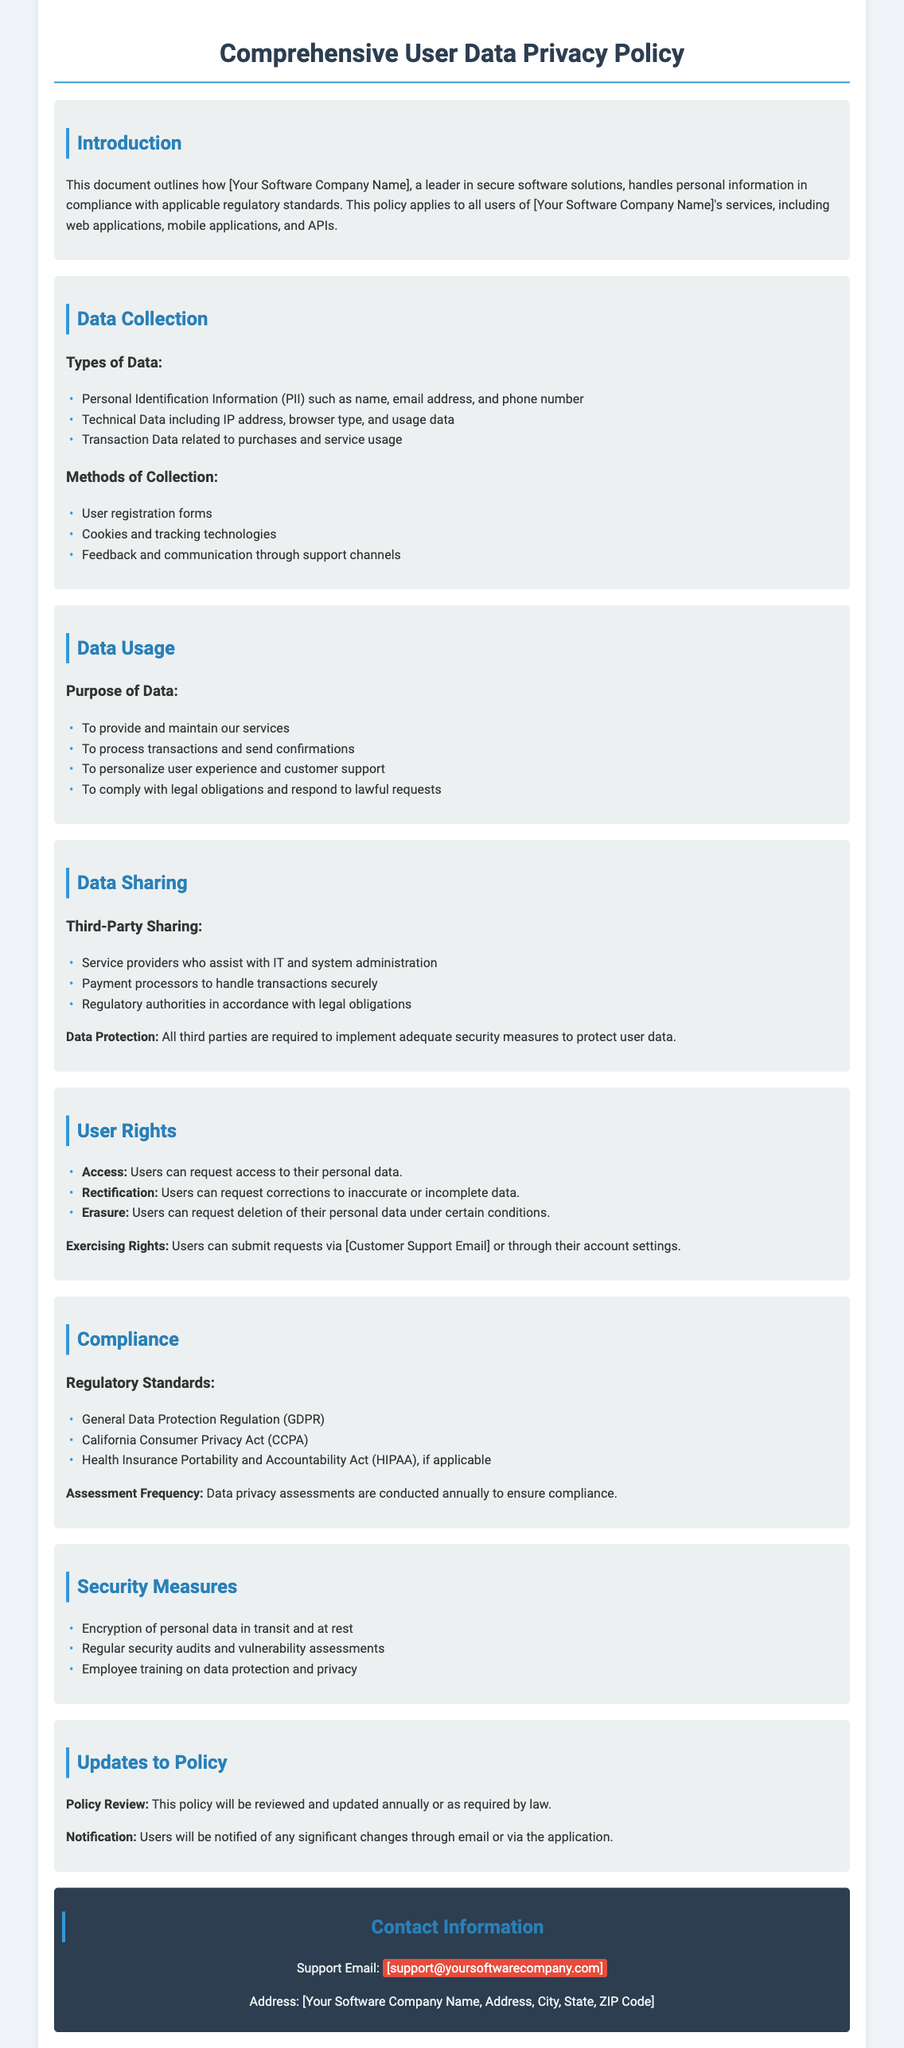What is the name of the policy document? The title is indicated at the top of the document as "Comprehensive User Data Privacy Policy".
Answer: Comprehensive User Data Privacy Policy What types of data are collected? The document lists examples of data types, including Personal Identification Information, Technical Data, and Transaction Data.
Answer: Personal Identification Information, Technical Data, Transaction Data What can users request under their rights? The document describes specific rights including Access, Rectification, and Erasure of personal data.
Answer: Access, Rectification, Erasure Which regulatory standards are mentioned in the document? The document lists applicable regulations such as GDPR, CCPA, and HIPAA.
Answer: GDPR, CCPA, HIPAA What is the frequency of data privacy assessments? The document specifies how often assessments are conducted to ensure compliance.
Answer: Annually Who can users contact for support? The contact information section provides a support email for users needing assistance.
Answer: support@yoursoftwarecompany.com What security measure is mentioned for personal data? The document outlines specific security measures, including encryption and audits.
Answer: Encryption of personal data What is stated about policy updates? The document mentions how often the policy is reviewed and how users will be notified.
Answer: Annually or as required by law 